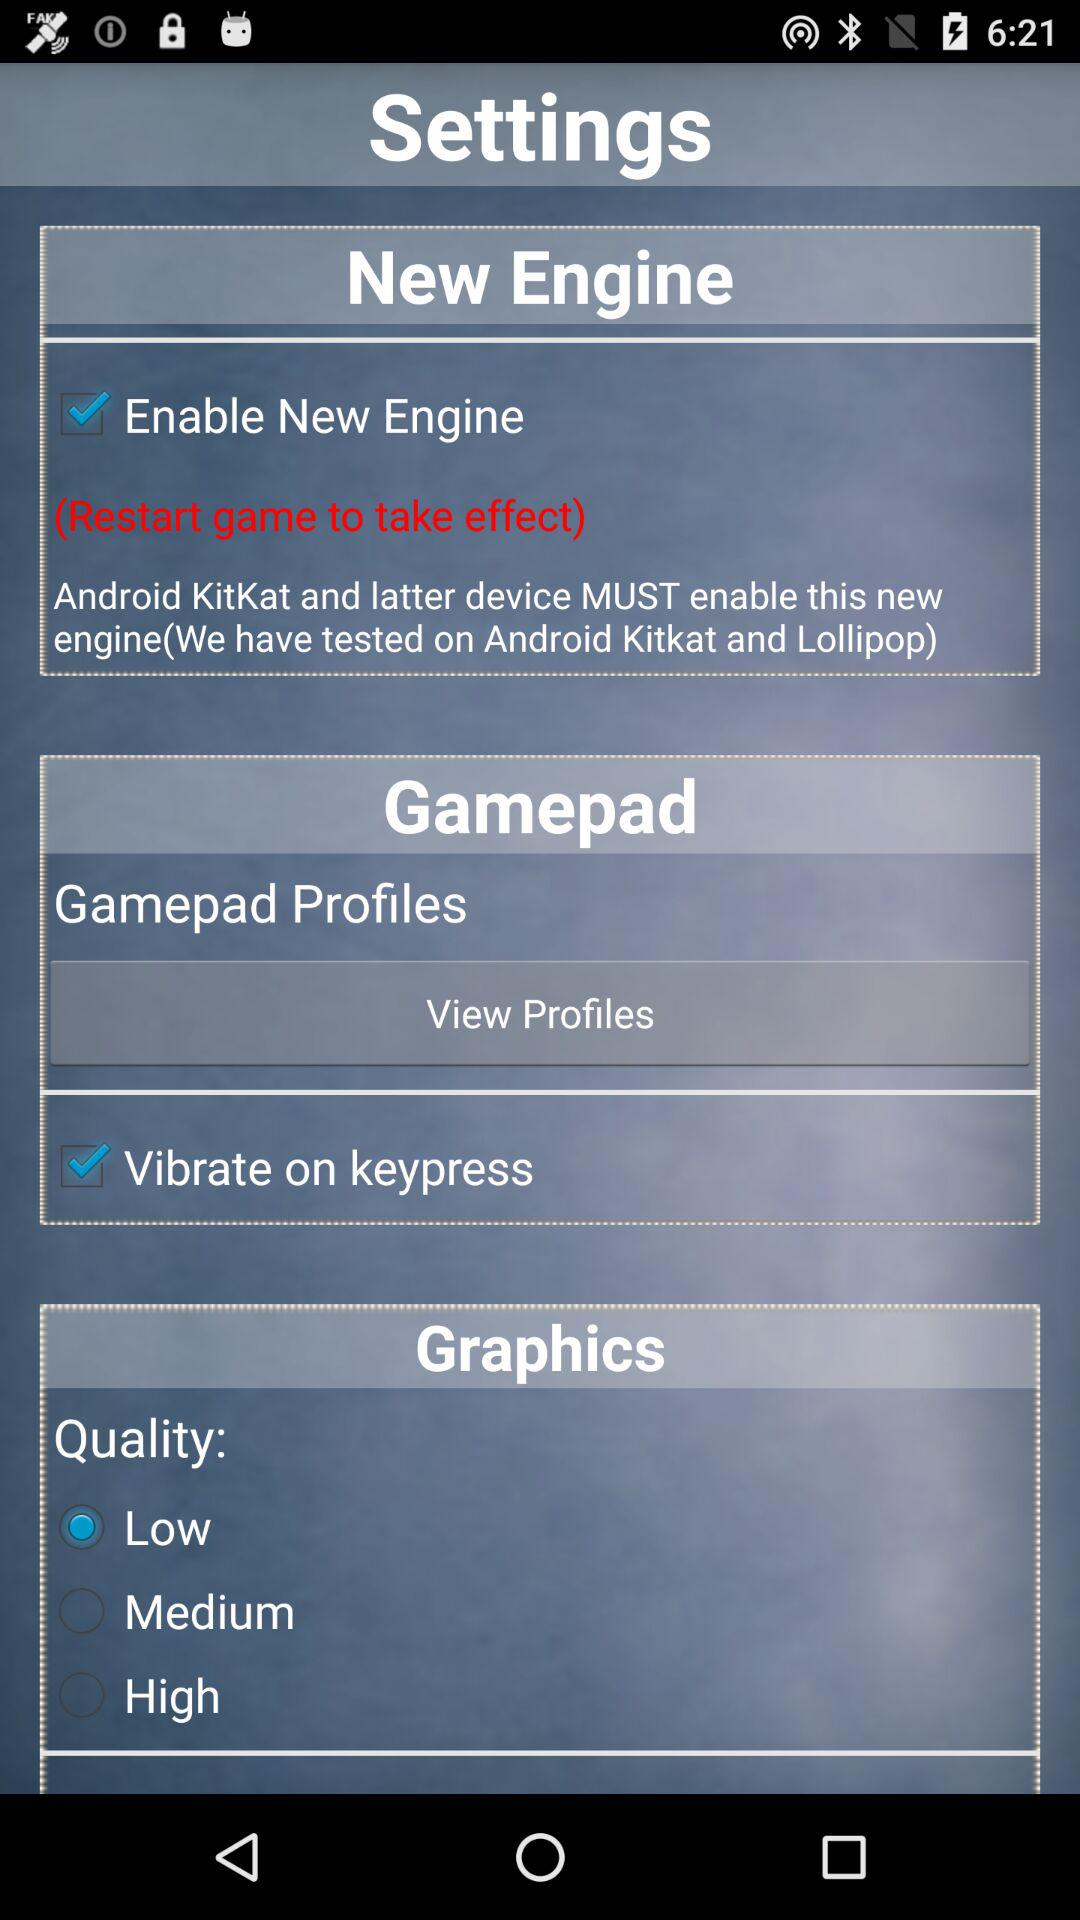How many items are in the settings menu?
Answer the question using a single word or phrase. 3 